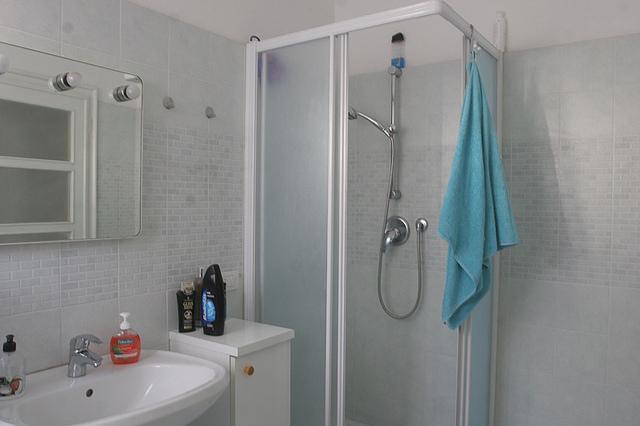How many types of soap are on the counter?
Give a very brief answer. 2. 